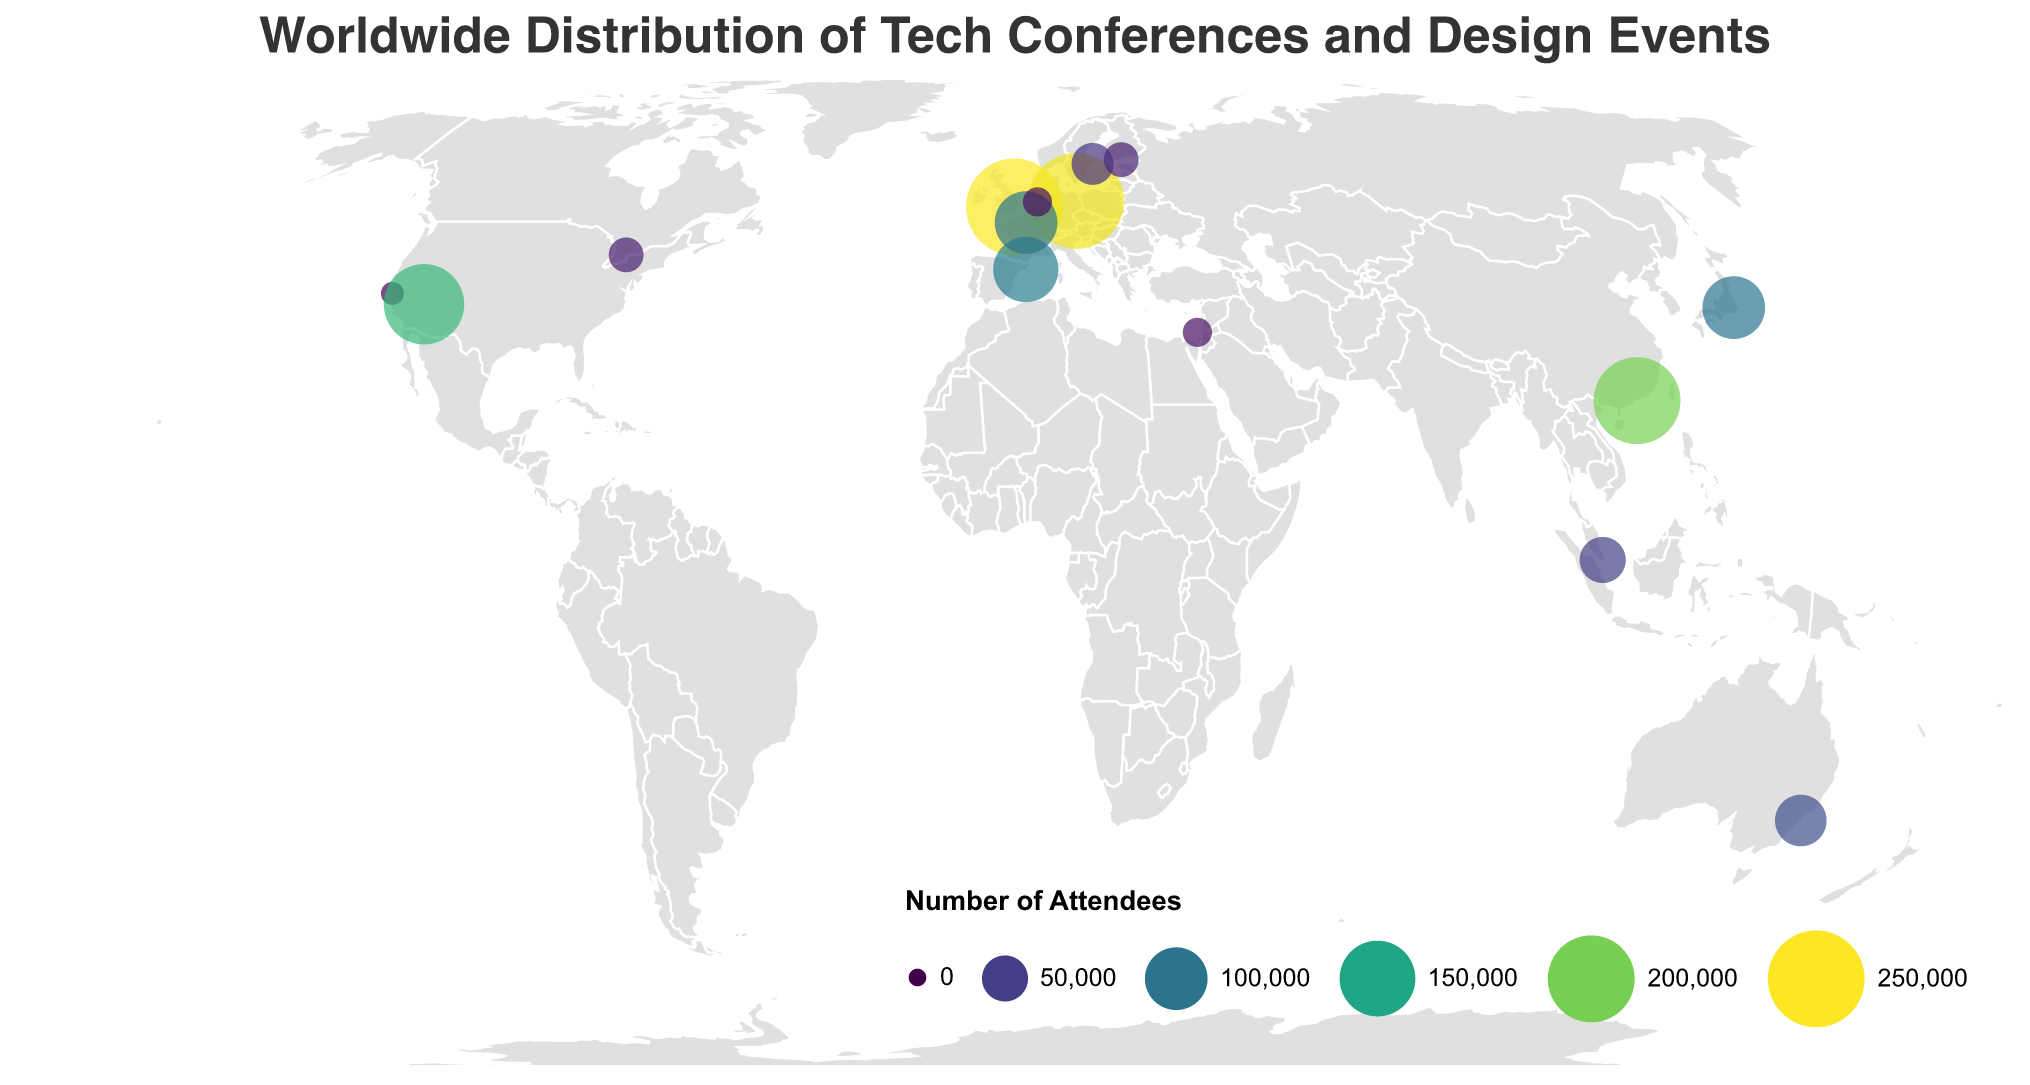Which city hosts the event with the highest number of attendees? Look at the largest circles on the map, indicating high numbers of attendees. London has the London Design Festival with 250,000 attendees, the highest among all events.
Answer: London Which two cities in the USA host tech conferences or design events? Identify the data points located within the USA's geographic boundaries. San Francisco hosts Apple WWDC, and Las Vegas hosts CES.
Answer: San Francisco and Las Vegas How many events have an attendee count of 100,000 or more? Count the number of circles that have a size corresponding to 100,000 or more in attendees. These events are in London, Berlin, Tokyo, Barcelona, Paris, Las Vegas, and Shenzhen.
Answer: 7 Which city hosts the largest design event in terms of attendees, and what is the event name? Compare the circles related to design events specifically by their size. The London Design Festival in London has the highest number of attendees (250,000).
Answer: London, London Design Festival Calculate the total number of attendees at events in European cities. Sum the attendees in London (250,000), Berlin (245,000), Barcelona (109,000), Paris (100,000), Helsinki (25,000), Amsterdam (15,000), and Stockholm (40,000). The total is 779,000.
Answer: 779,000 Which region (continent) hosts the majority of the tech conferences and design events? Count the number of events per continent: Europe (7), North America (3), Asia (4), Oceania (1). Europe hosts the majority of events.
Answer: Europe Identify the city with a design event in the Southern Hemisphere and provide the attendee count. Locate the events with negative latitude values indicating the Southern Hemisphere. Sydney hosts the Sydney Design Festival with 65,000 attendees.
Answer: Sydney, 65,000 What are the two least attended events, and where are they located? Identify the smallest circles on the map. The events are the TNW Conference in Amsterdam and DLD Tel Aviv in Tel Aviv, each with 15,000 attendees.
Answer: Amsterdam (TNW Conference) and Tel Aviv (DLD Tel Aviv) Which city hosts the second largest tech conference, and what is the event's attendee count? San Francisco hosts Apple WWDC with 6,000 attendees, Las Vegas hosts CES with 170,000 attendees. Therefore, Barcelona with Mobile World Congress having 109,000 attendees is the second largest.
Answer: Barcelona, 109,000 